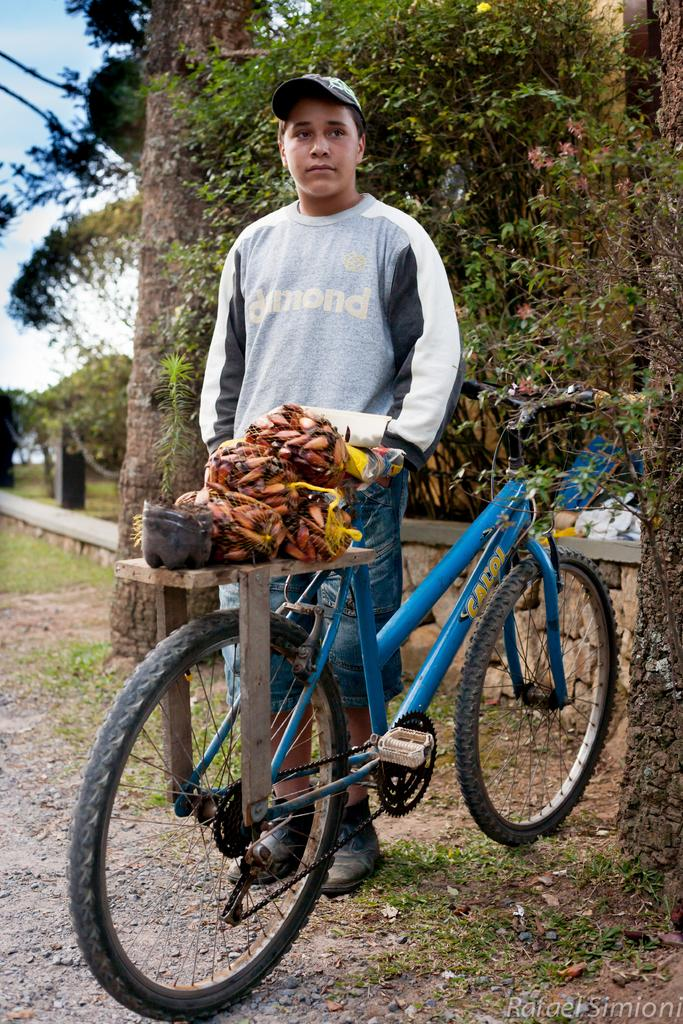What is the person in the image doing? The person is standing beside a bicycle. What is on the bicycle? There are objects placed on the bicycle. What can be seen in the background of the image? There are trees and grass in the background of the image. What type of rhythm can be heard coming from the animal in the image? There is no animal present in the image, and therefore no rhythm can be heard. 